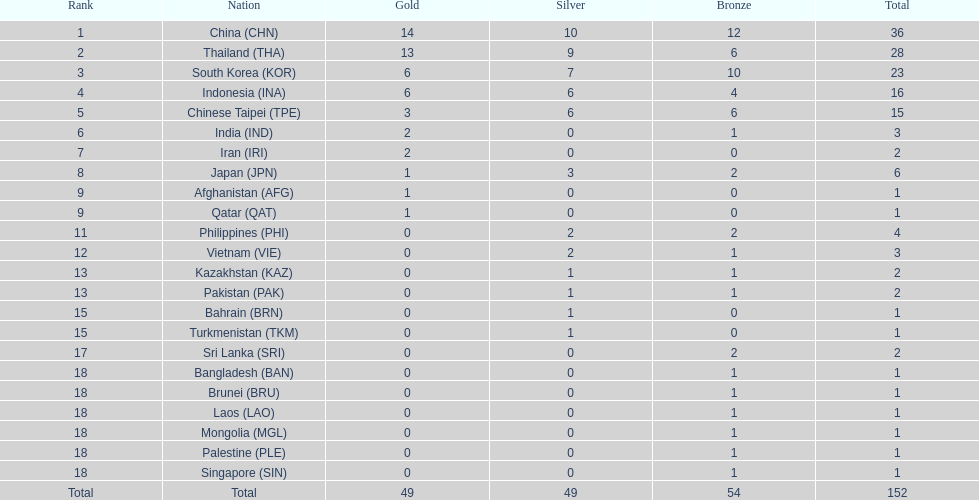Did the philippines or kazakhstan have a higher number of total medals? Philippines. 